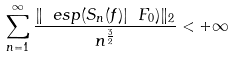<formula> <loc_0><loc_0><loc_500><loc_500>\sum _ { n = 1 } ^ { \infty } \frac { \| \ e s p ( S _ { n } ( f ) | \ F _ { 0 } ) \| _ { 2 } } { n ^ { \frac { 3 } { 2 } } } < + \infty</formula> 